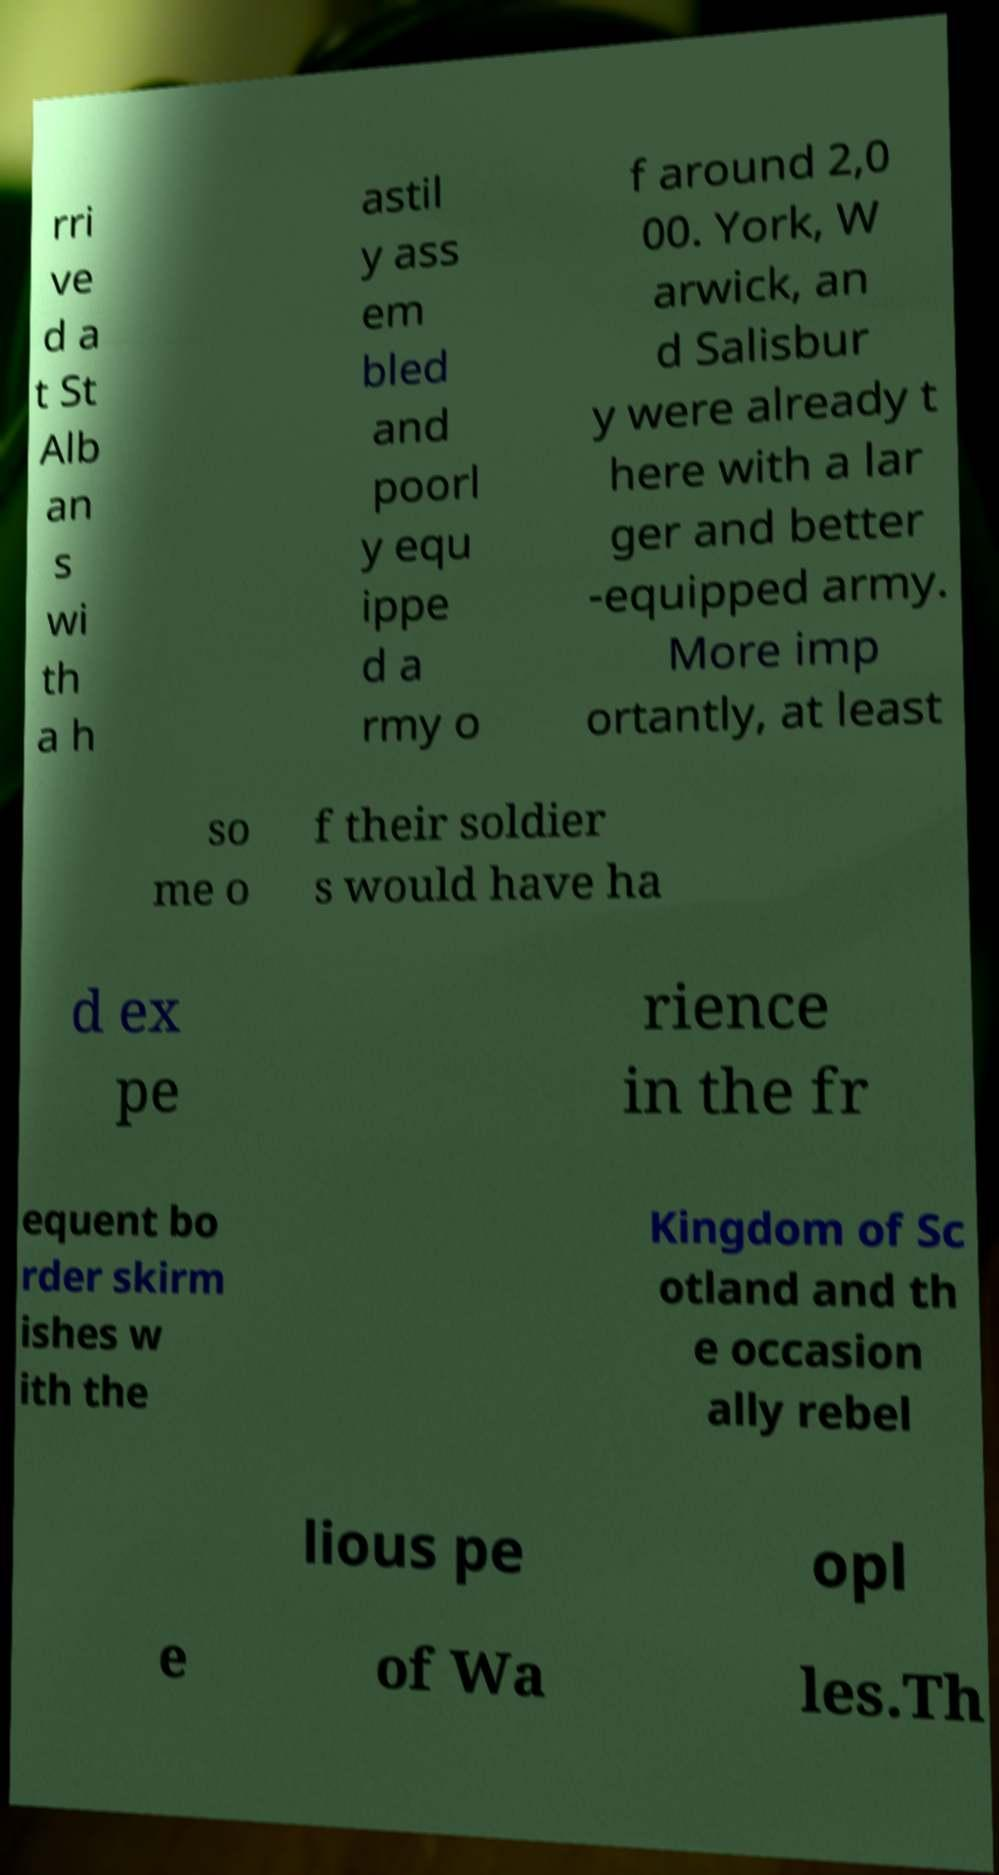For documentation purposes, I need the text within this image transcribed. Could you provide that? rri ve d a t St Alb an s wi th a h astil y ass em bled and poorl y equ ippe d a rmy o f around 2,0 00. York, W arwick, an d Salisbur y were already t here with a lar ger and better -equipped army. More imp ortantly, at least so me o f their soldier s would have ha d ex pe rience in the fr equent bo rder skirm ishes w ith the Kingdom of Sc otland and th e occasion ally rebel lious pe opl e of Wa les.Th 